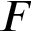<formula> <loc_0><loc_0><loc_500><loc_500>F</formula> 